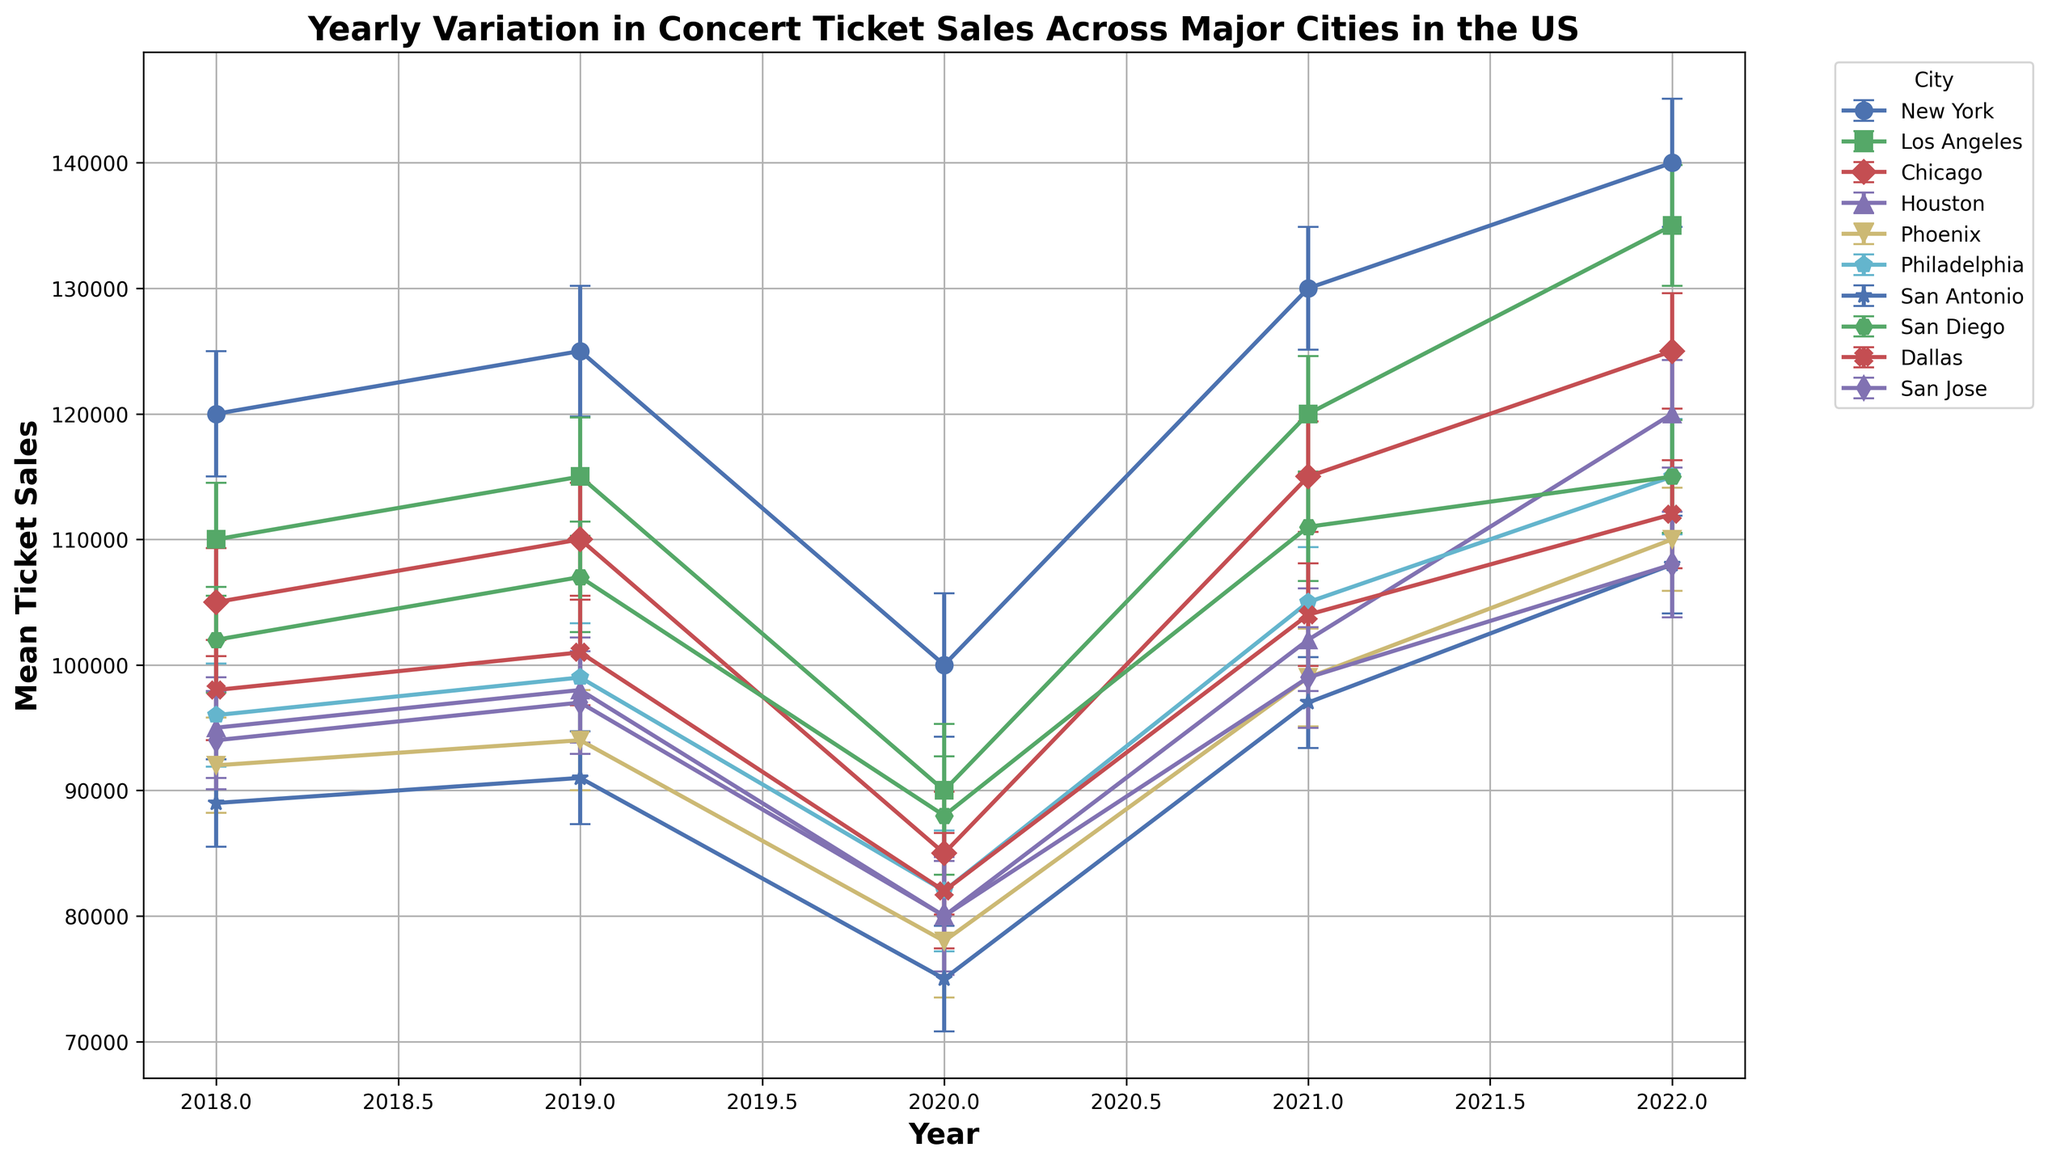Which city saw the highest mean ticket sales in 2022? To find the city with the highest mean ticket sales in 2022, look at the plotted data points for 2022 and compare their heights. The city with the tallest plotted point will have the highest mean ticket sales.
Answer: New York How did the ticket sales in New York change from 2018 to 2020? Look at the errorbar points for New York in 2018, 2019, and 2020. Note the values and observe the trend. New York had mean ticket sales of 120,000 in 2018, which increased to 125,000 in 2019, then dropped to 100,000 in 2020.
Answer: Increased, then decreased Which city had the largest standard deviation in ticket sales for any given year? Examine the lengths of the errorbars for all cities across all years. The one with the longest errorbar represents the largest standard deviation.
Answer: New York in 2020 Did any city experience a decrease in ticket sales from 2019 to 2020 and then an increase from 2020 to 2021? Check the trajectories of the points for each city from 2019 to 2020 and from 2020 to 2021 to see if they first decrease and then increase.
Answer: Yes, all cities experienced this Which two cities had the smallest difference in mean ticket sales in 2021? Compare the mean ticket sales values for all cities in 2021 and identify the two closest values.
Answer: Los Angeles and New York What are the cities with consistently increasing ticket sales from 2020 to 2022? Check the errorbar points' trend for each city from 2020 to 2022. The cities with all points increasing year-over-year in this period will be consistent risers.
Answer: New York, Los Angeles, Houston, Philadelphia, Phoenix, San Antonio, San Jose What was the average mean ticket sales for all cities combined in 2020? Sum the mean ticket sales for all cities in 2020 and divide by the number of cities (10). The values are: (100,000 + 90,000 + 85,000 + 80,000 + 78,000 + 82,000 + 75,000 + 88,000 + 82,000 + 80,000) = 840,000. Average = 840,000 / 10.
Answer: 84,000 Which city’s ticket sales showed the least variation over the years? Look at the trends of the errorbar points for each city. The city with the least variation will have the most stable line without large fluctuations.
Answer: San Jose What visual trend can you observe in ticket sales in 2020 across all cities? Visually inspect the chart for the year 2020. Notice if there's a common trend among all the data points. In 2020, all cities show a noticeable dip in ticket sales.
Answer: A general decrease What city had the highest ‘bounce back’ in ticket sales from 2020 to 2022? To find this, calculate the difference between 2022 and 2020 ticket sales for each city, then determine the highest difference. Compare points for 2022 and 2020 for each city and check the increments.
Answer: Houston 